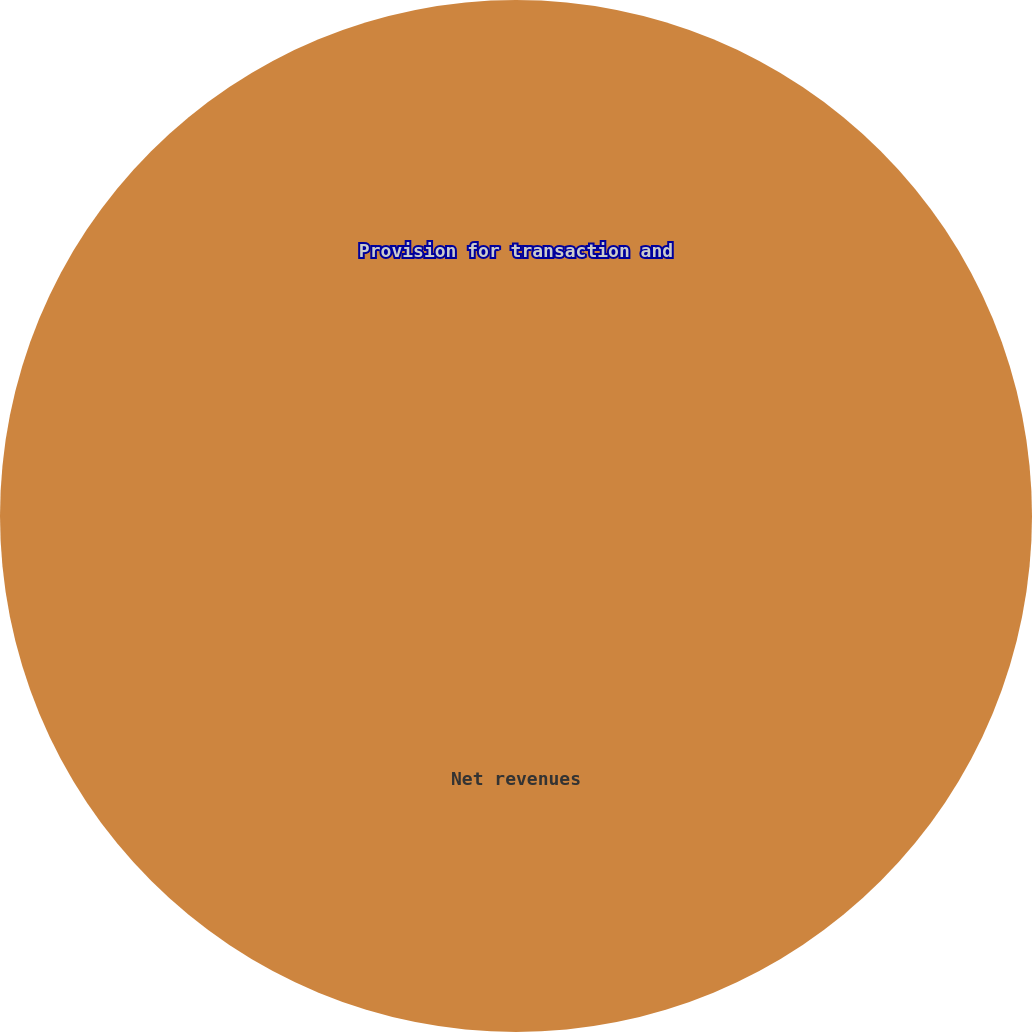Convert chart to OTSL. <chart><loc_0><loc_0><loc_500><loc_500><pie_chart><fcel>Net revenues<fcel>Provision for transaction and<nl><fcel>100.0%<fcel>0.0%<nl></chart> 